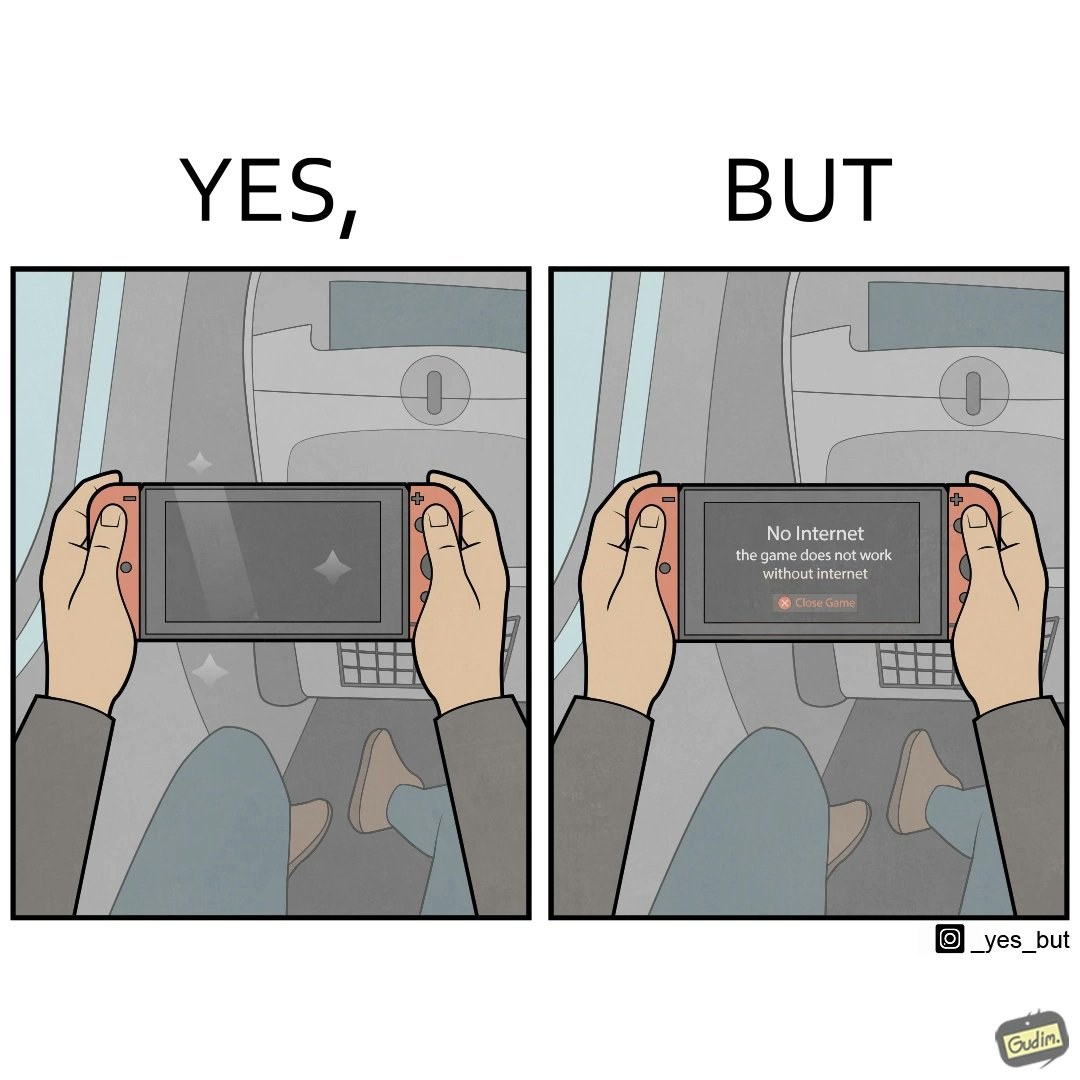What is the satirical meaning behind this image? The image is ironic, as the person is holding the game console to play a game during the flight. However, the person is unable to play the game, as the game requires internet (as is the case with many modern games), and internet is unavailable in many lights. 